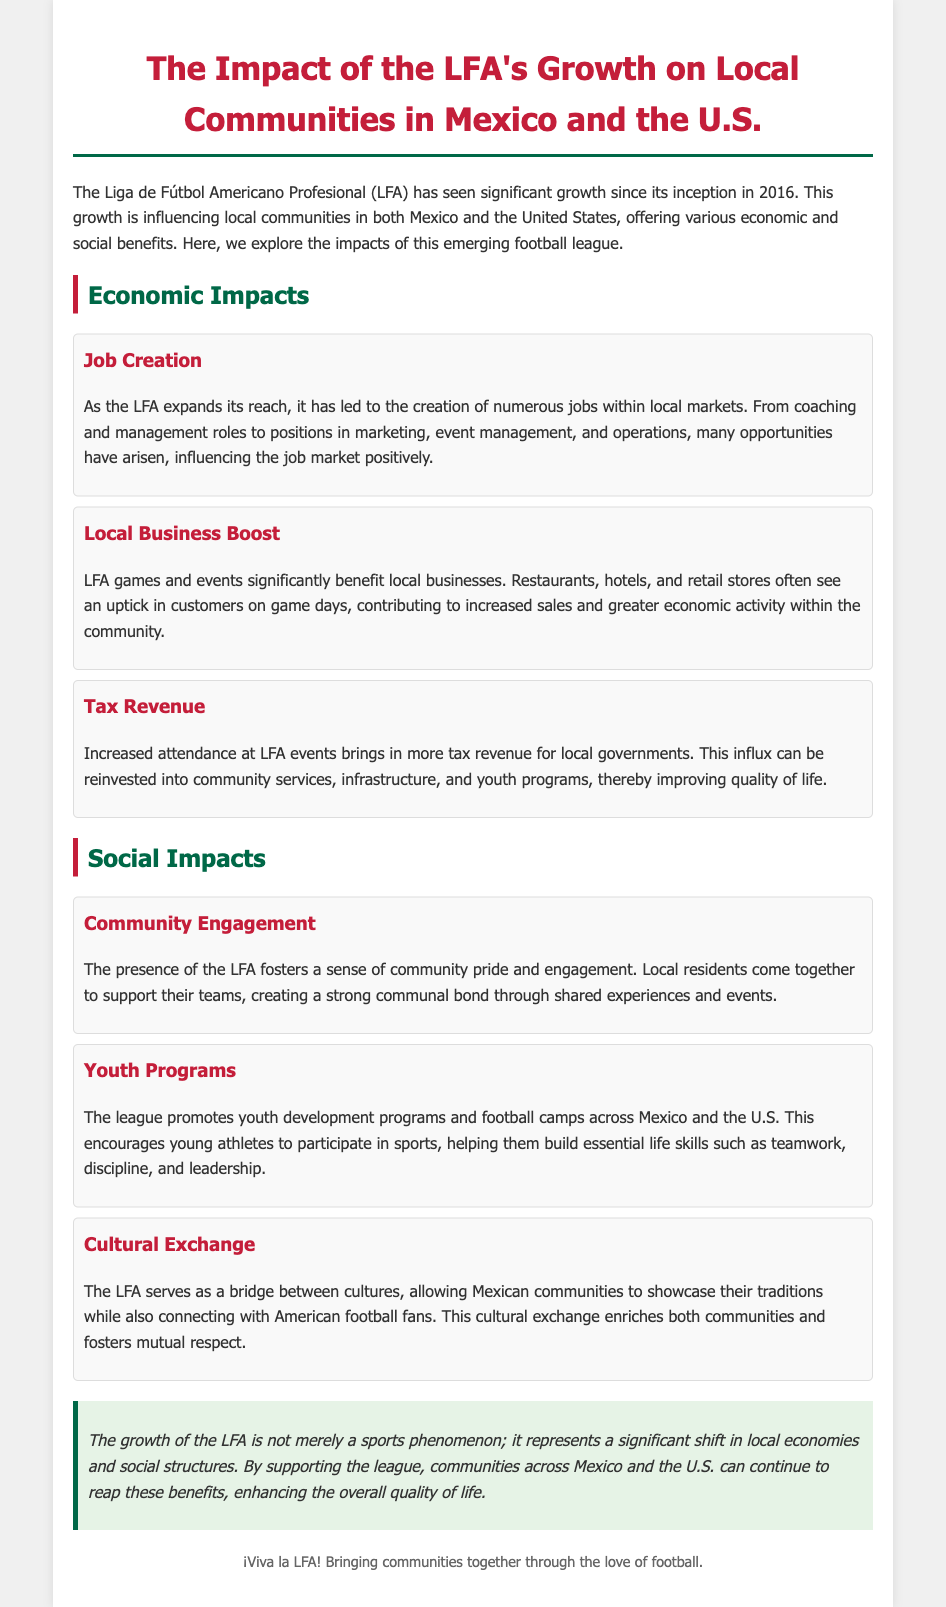What year was the LFA established? The document states that the LFA was founded in 2016.
Answer: 2016 What are some economic benefits mentioned in the document? The document lists job creation, local business boost, and tax revenue as economic benefits.
Answer: Job creation, local business boost, tax revenue How does the LFA impact local businesses? The document mentions that LFA games benefit local businesses by increasing customer traffic on game days.
Answer: Increases customer traffic What is one social benefit provided by the LFA? The document highlights community engagement as a social benefit of the LFA.
Answer: Community engagement Which youth development programs does the LFA promote? The document states that the LFA promotes youth development programs and football camps.
Answer: Youth development programs, football camps What is the conclusion about the LFA's growth? The conclusion emphasizes that the LFA's growth represents a significant shift in local economies and social structures.
Answer: Significant shift in local economies and social structures What colors are used in the document's headings? The headings in the document use the colors red and green.
Answer: Red and green What role does the LFA play in cultural exchange? The document describes the LFA as a bridge between cultures, enriching both Mexican and American communities.
Answer: A bridge between cultures 